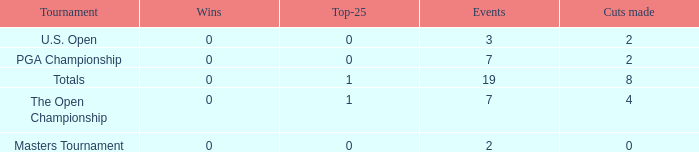What is the Wins of the Top-25 of 1 and 7 Events? 0.0. 